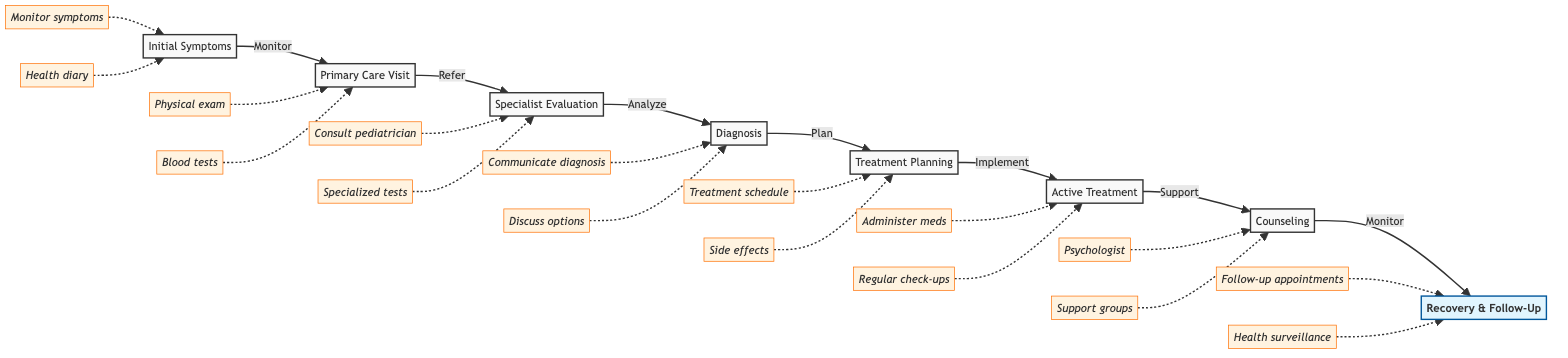What is the first stage in the diagnosis journey? The first stage in the diagram is labeled as "Initial Symptoms." This is visually identified at the beginning of the flowchart and represents the starting point for the journey of diagnosing and treating a childhood illness.
Answer: Initial Symptoms How many stages are included in the flowchart? There are eight distinct stages in the flowchart, which can be counted from the initial symptoms to recovery and follow-up.
Answer: 8 What action is taken during the "Primary Care Visit"? During the "Primary Care Visit," one of the key actions taken is the "Physical examination." This action is directly linked to the stage of visiting a primary care physician.
Answer: Physical examination Which stage follows "Diagnosis"? The stage that follows "Diagnosis" is "Treatment Planning." This can be seen as an arrow points from diagnosis directly to treatment planning in the flowchart, indicating the sequential flow.
Answer: Treatment Planning What is an action associated with "Active Treatment"? One action associated with "Active Treatment" is "Administer medications." This is specified in the flowchart under the stage of active treatment, indicating a crucial part of the treatment process.
Answer: Administer medications What relationship exists between "Support and Counseling" and "Recovery and Follow-Up"? The relationship between "Support and Counseling" and "Recovery and Follow-Up" is sequential; after receiving support and counseling, the next stage is monitoring progress in recovery and follow-up. This flow is indicated by the arrow connecting these two stages.
Answer: Sequential relationship What specialized tests are conducted after referral to a specialist? After referral to a specialist, the specialized tests conducted include "Additional specialized tests (e.g., imaging, advanced blood tests)." This indicates that further evaluation involves specific medical tests to assist in the diagnosis.
Answer: Additional specialized tests How is the treatment plan developed? The treatment plan is developed by "Collaborating with healthcare providers," which signifies teamwork among medical professionals to ensure a comprehensive plan is constructed for the patient.
Answer: Collaborating with healthcare providers What kind of support may be accessed during "Support and Counseling"? During "Support and Counseling," "Join support groups" is one type of support that can be accessed. This highlights the importance of social support during the treatment process.
Answer: Join support groups 